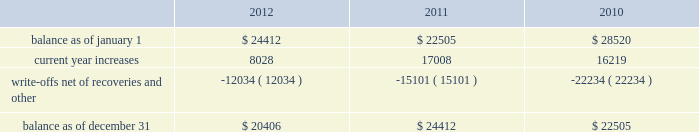American tower corporation and subsidiaries notes to consolidated financial statements when they are determined uncollectible .
Such determination includes analysis and consideration of the particular conditions of the account .
Changes in the allowances were as follows for the years ended december 31 , ( in thousands ) : .
Functional currency 2014as a result of changes to the organizational structure of the company 2019s subsidiaries in latin america in 2010 , the company determined that effective january 1 , 2010 , the functional currency of its foreign subsidiary in brazil is the brazilian real .
From that point forward , all assets and liabilities held by the subsidiary in brazil are translated into u.s .
Dollars at the exchange rate in effect at the end of the applicable reporting period .
Revenues and expenses are translated at the average monthly exchange rates and the cumulative translation effect is included in equity .
The change in functional currency from u.s .
Dollars to brazilian real gave rise to an increase in the net value of certain non-monetary assets and liabilities .
The aggregate impact on such assets and liabilities was $ 39.8 million with an offsetting increase in accumulated other comprehensive income during the year ended december 31 , 2010 .
As a result of the renegotiation of the company 2019s agreements with grupo iusacell , s.a .
De c.v .
( 201ciusacell 201d ) , which included , among other changes , converting iusacell 2019s contractual obligations to the company from u.s .
Dollars to mexican pesos , the company determined that effective april 1 , 2010 , the functional currency of certain of its foreign subsidiaries in mexico is the mexican peso .
From that point forward , all assets and liabilities held by those subsidiaries in mexico are translated into u.s .
Dollars at the exchange rate in effect at the end of the applicable reporting period .
Revenues and expenses are translated at the average monthly exchange rates and the cumulative translation effect is included in equity .
The change in functional currency from u.s .
Dollars to mexican pesos gave rise to a decrease in the net value of certain non-monetary assets and liabilities .
The aggregate impact on such assets and liabilities was $ 33.6 million with an offsetting decrease in accumulated other comprehensive income .
The functional currency of the company 2019s other foreign operating subsidiaries is also the respective local currency .
All assets and liabilities held by the subsidiaries are translated into u.s .
Dollars at the exchange rate in effect at the end of the applicable fiscal reporting period .
Revenues and expenses are translated at the average monthly exchange rates .
The cumulative translation effect is included in equity as a component of accumulated other comprehensive income .
Foreign currency transaction gains and losses are recognized in the consolidated statements of operations and are the result of transactions of a subsidiary being denominated in a currency other than its functional currency .
Cash and cash equivalents 2014cash and cash equivalents include cash on hand , demand deposits and short-term investments , including money market funds , with remaining maturities of three months or less when acquired , whose cost approximates fair value .
Restricted cash 2014the company classifies as restricted cash all cash pledged as collateral to secure obligations and all cash whose use is otherwise limited by contractual provisions , including cash on deposit in reserve accounts relating to the commercial mortgage pass-through certificates , series 2007-1 issued in the company 2019s securitization transaction and the secured cellular site revenue notes , series 2010-1 class c , series 2010-2 class c and series 2010-2 class f , assumed by the company as a result of the acquisition of certain legal entities from unison holdings , llc and unison site management ii , l.l.c .
( collectively , 201cunison 201d ) . .
In 2012 what was the percentage change in the allowances? 
Computations: ((20406 - 24412) / 24412)
Answer: -0.1641. 